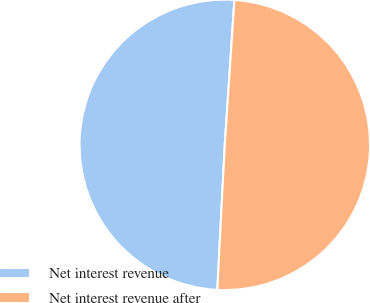Convert chart to OTSL. <chart><loc_0><loc_0><loc_500><loc_500><pie_chart><fcel>Net interest revenue<fcel>Net interest revenue after<nl><fcel>50.24%<fcel>49.76%<nl></chart> 